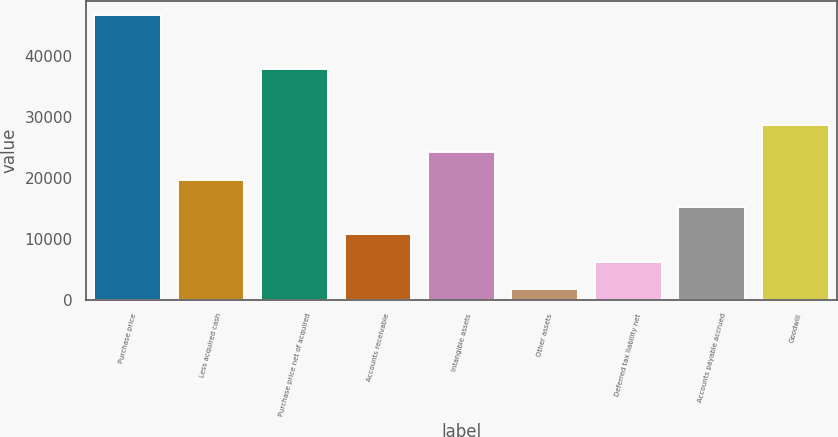<chart> <loc_0><loc_0><loc_500><loc_500><bar_chart><fcel>Purchase price<fcel>Less acquired cash<fcel>Purchase price net of acquired<fcel>Accounts receivable<fcel>Intangible assets<fcel>Other assets<fcel>Deferred tax liability net<fcel>Accounts payable accrued<fcel>Goodwill<nl><fcel>46683<fcel>19704<fcel>37827<fcel>10711<fcel>24200.5<fcel>1718<fcel>6214.5<fcel>15207.5<fcel>28697<nl></chart> 